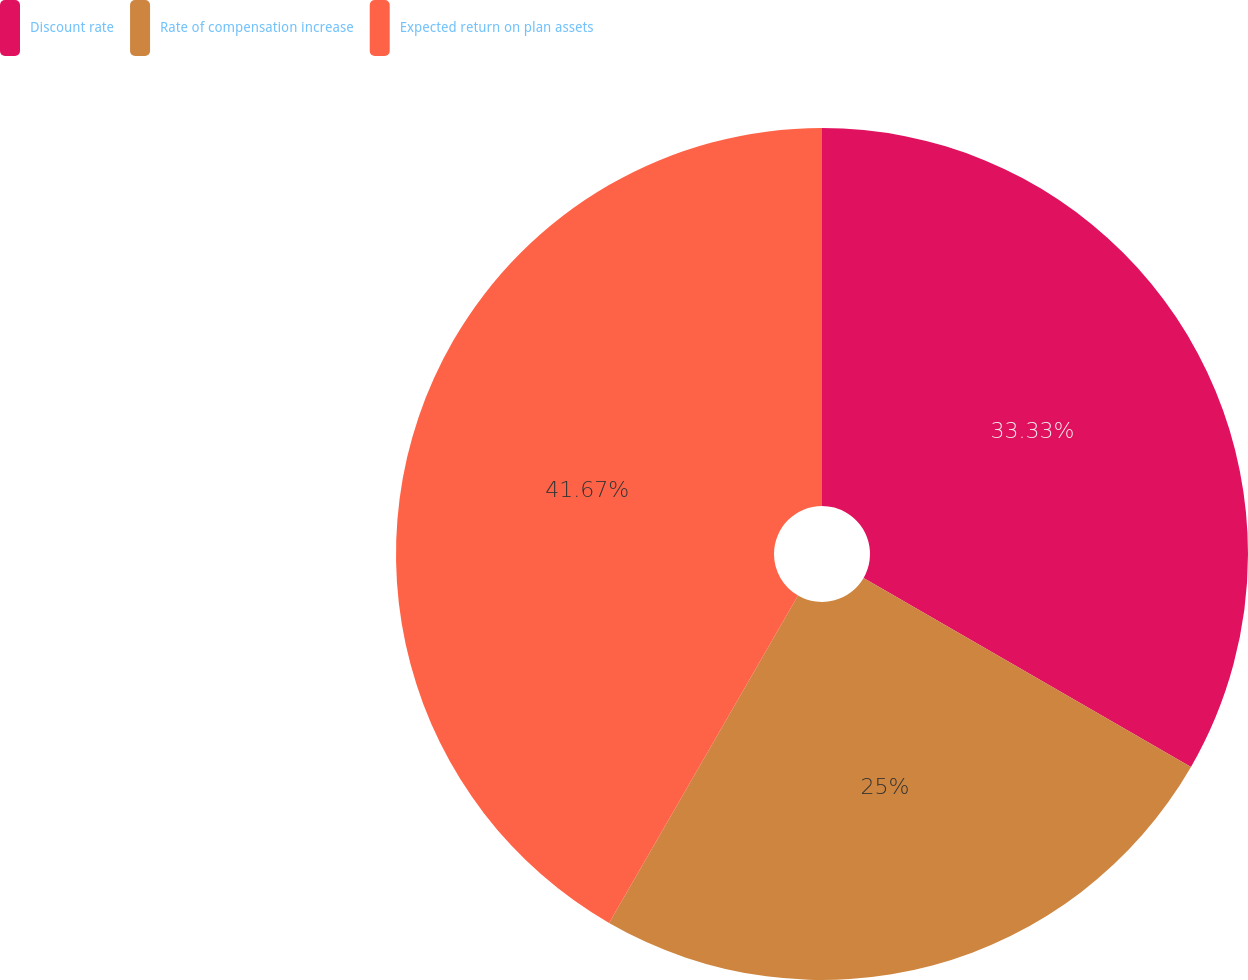Convert chart to OTSL. <chart><loc_0><loc_0><loc_500><loc_500><pie_chart><fcel>Discount rate<fcel>Rate of compensation increase<fcel>Expected return on plan assets<nl><fcel>33.33%<fcel>25.0%<fcel>41.67%<nl></chart> 